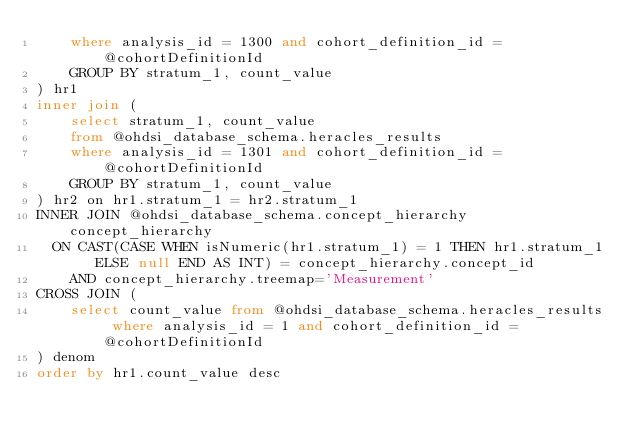<code> <loc_0><loc_0><loc_500><loc_500><_SQL_>    where analysis_id = 1300 and cohort_definition_id = @cohortDefinitionId
		GROUP BY stratum_1, count_value
) hr1
inner join (
    select stratum_1, count_value 
    from @ohdsi_database_schema.heracles_results
    where analysis_id = 1301 and cohort_definition_id = @cohortDefinitionId
		GROUP BY stratum_1, count_value
) hr2 on hr1.stratum_1 = hr2.stratum_1
INNER JOIN @ohdsi_database_schema.concept_hierarchy concept_hierarchy
  ON CAST(CASE WHEN isNumeric(hr1.stratum_1) = 1 THEN hr1.stratum_1 ELSE null END AS INT) = concept_hierarchy.concept_id
    AND concept_hierarchy.treemap='Measurement'
CROSS JOIN (
    select count_value from @ohdsi_database_schema.heracles_results where analysis_id = 1 and cohort_definition_id = @cohortDefinitionId
) denom
order by hr1.count_value desc

</code> 